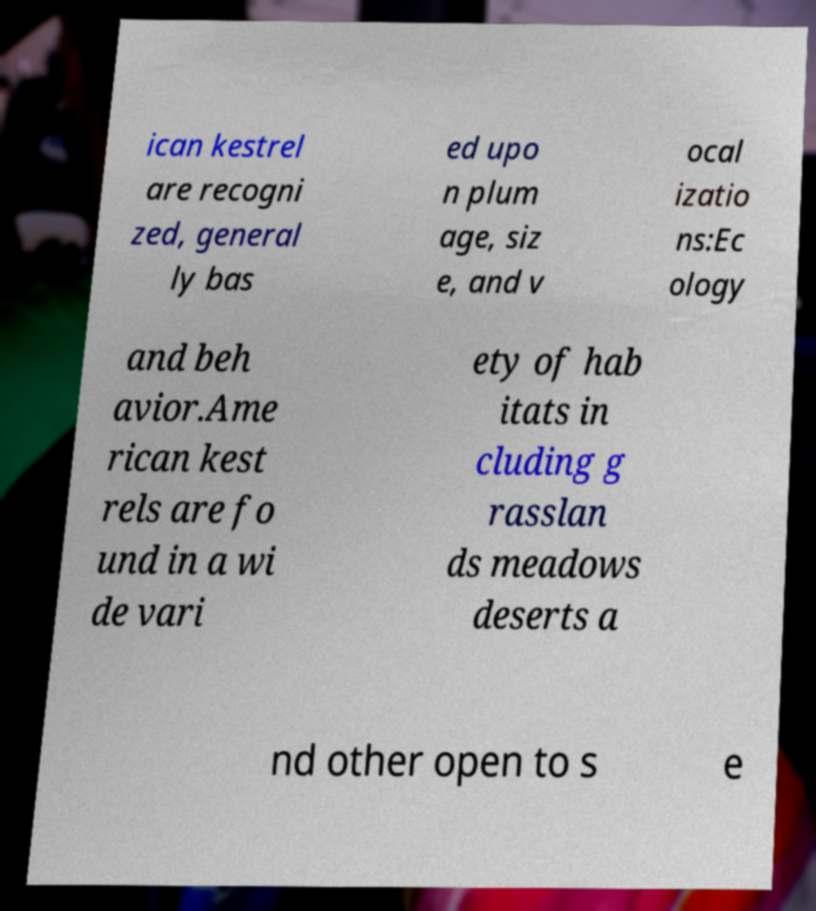Could you assist in decoding the text presented in this image and type it out clearly? ican kestrel are recogni zed, general ly bas ed upo n plum age, siz e, and v ocal izatio ns:Ec ology and beh avior.Ame rican kest rels are fo und in a wi de vari ety of hab itats in cluding g rasslan ds meadows deserts a nd other open to s e 